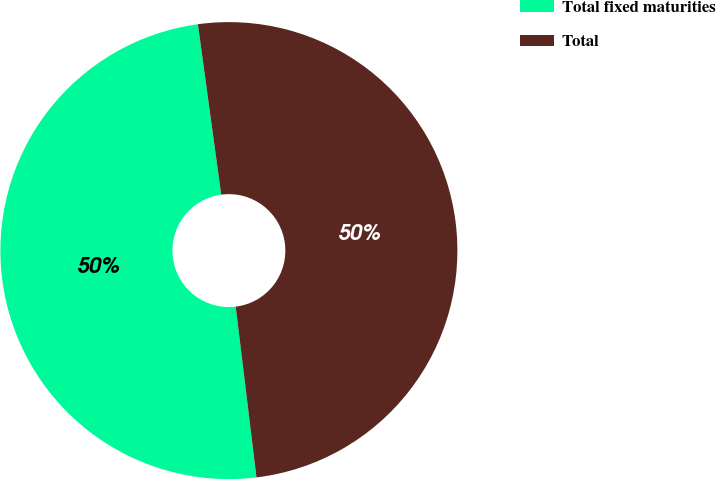<chart> <loc_0><loc_0><loc_500><loc_500><pie_chart><fcel>Total fixed maturities<fcel>Total<nl><fcel>49.76%<fcel>50.24%<nl></chart> 